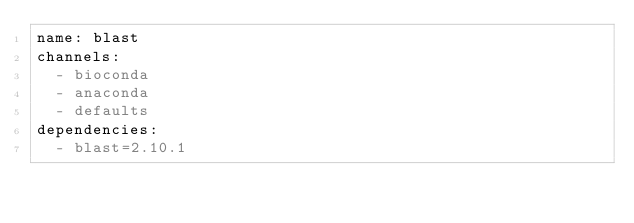<code> <loc_0><loc_0><loc_500><loc_500><_YAML_>name: blast
channels:
  - bioconda
  - anaconda
  - defaults
dependencies:
  - blast=2.10.1
</code> 